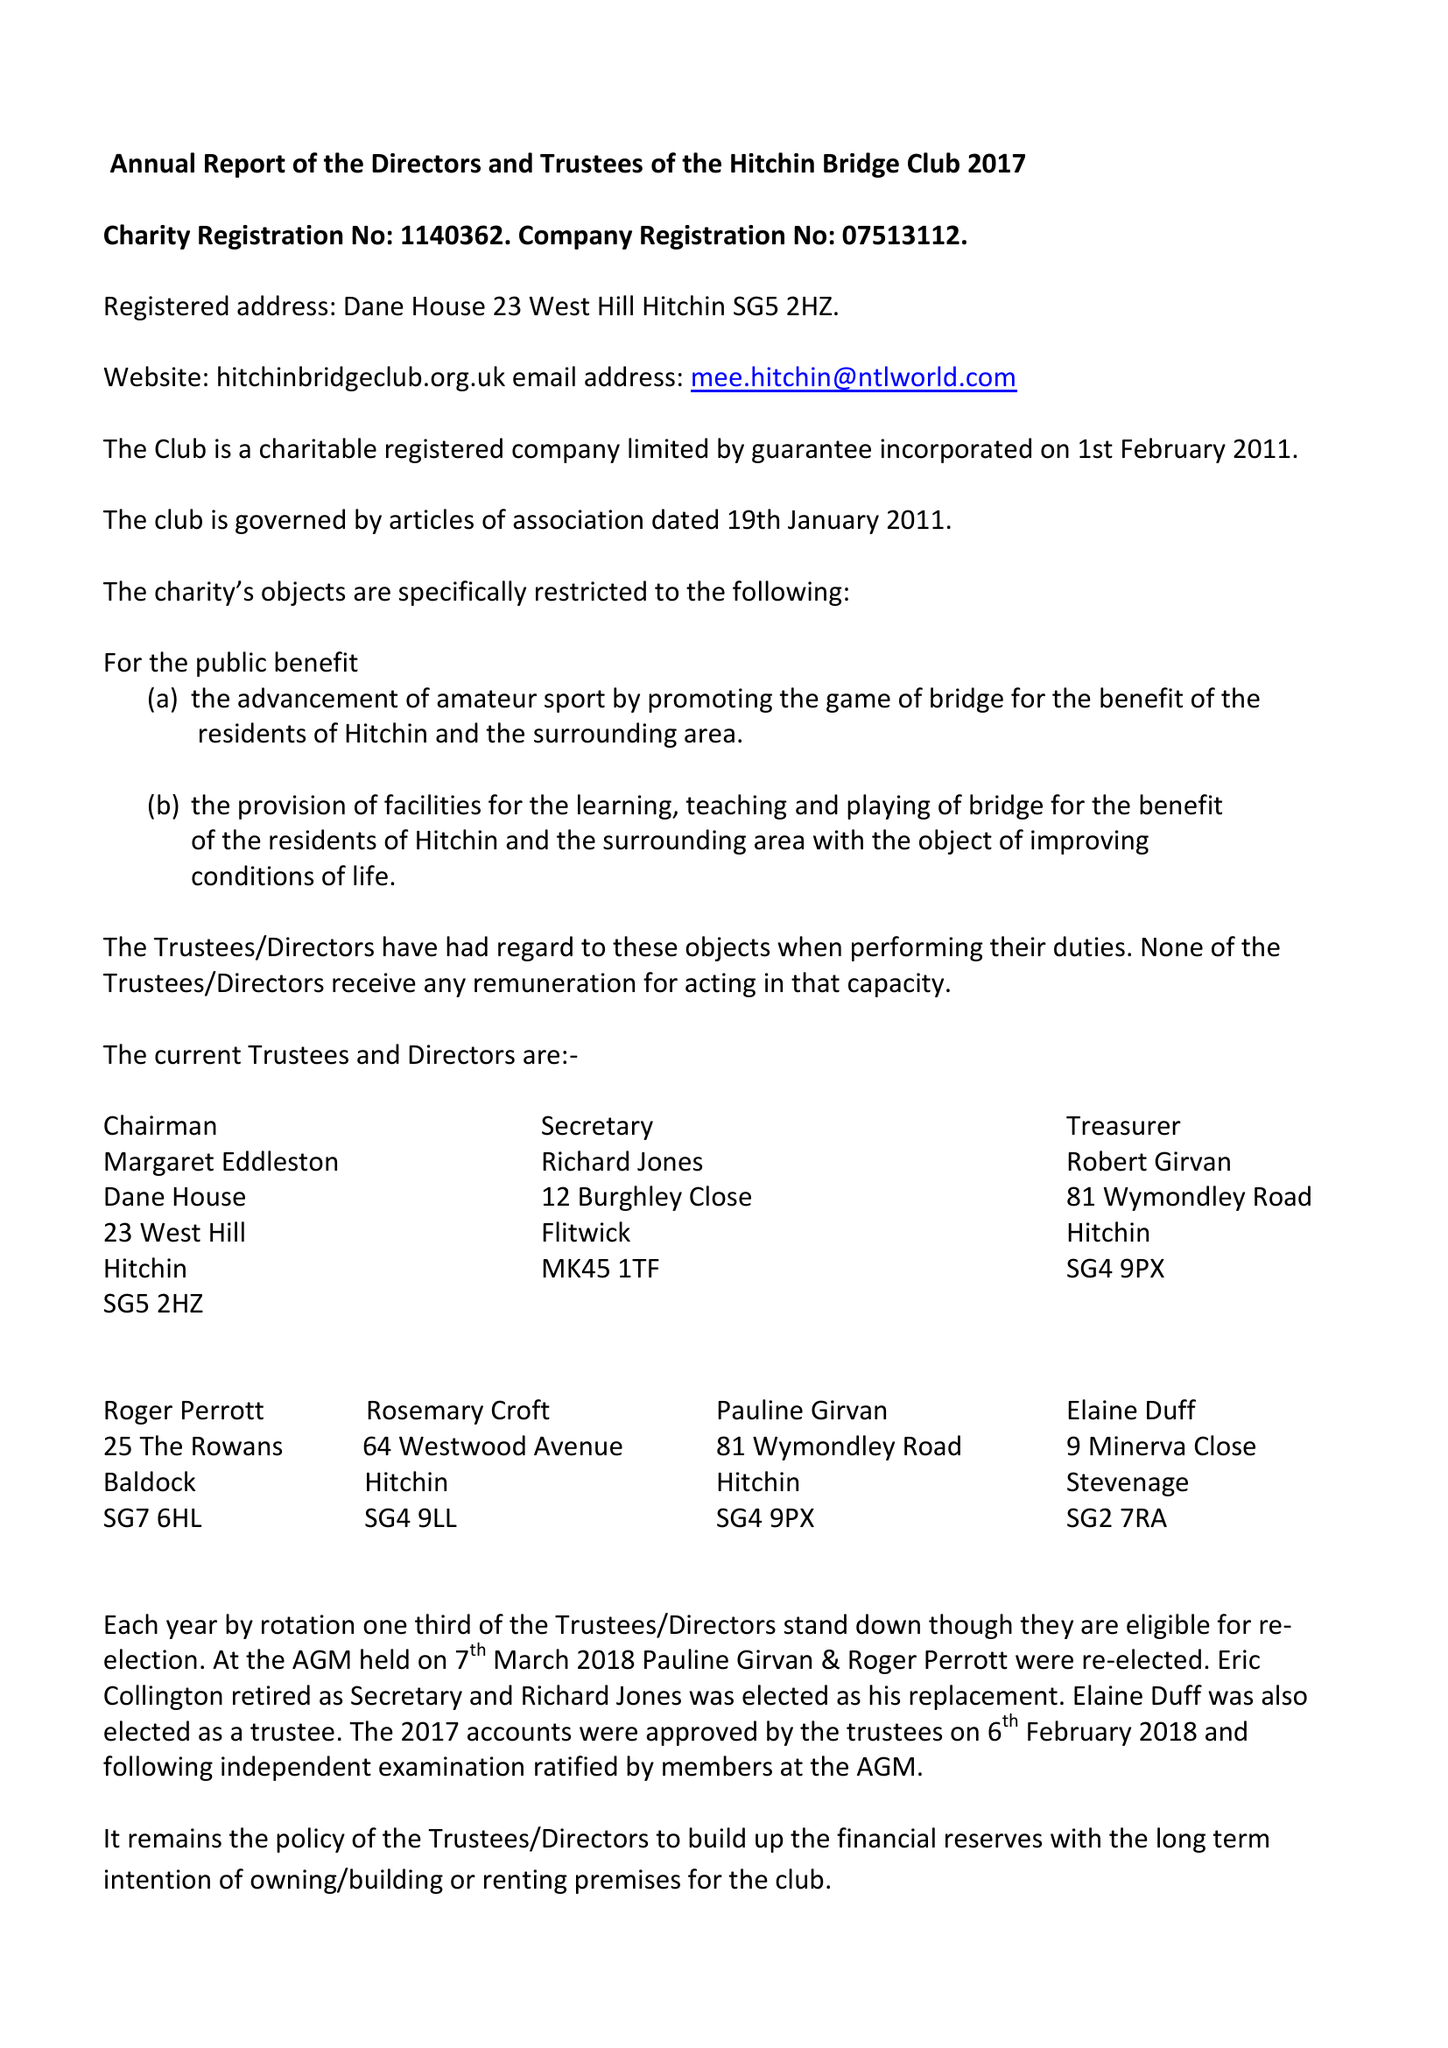What is the value for the address__post_town?
Answer the question using a single word or phrase. HITCHIN 